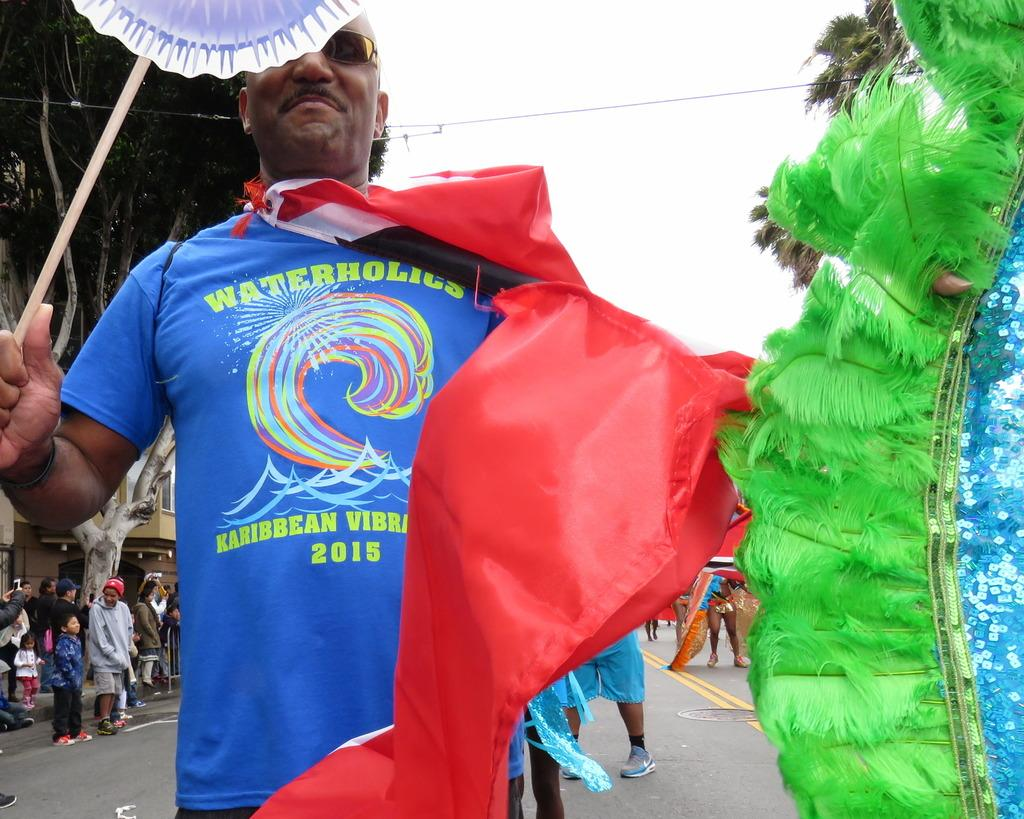Who is present in the image? There is a man in the image. What is the man wearing? The man is wearing a blue t-shirt. Who else is in the image besides the man? There are other people in the image. Where are the people located in the image? The people are on a road. What is the weather like in the image? The sky is cloudy in the image. What type of cheese can be seen on the man's elbow in the image? There is no cheese or man's elbow present in the image. What is the color of the mailbox near the people on the road? There is no mailbox visible in the image. 